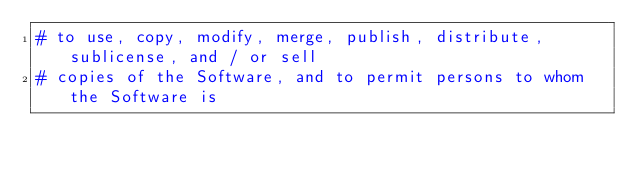<code> <loc_0><loc_0><loc_500><loc_500><_Python_># to use, copy, modify, merge, publish, distribute, sublicense, and / or sell
# copies of the Software, and to permit persons to whom the Software is</code> 